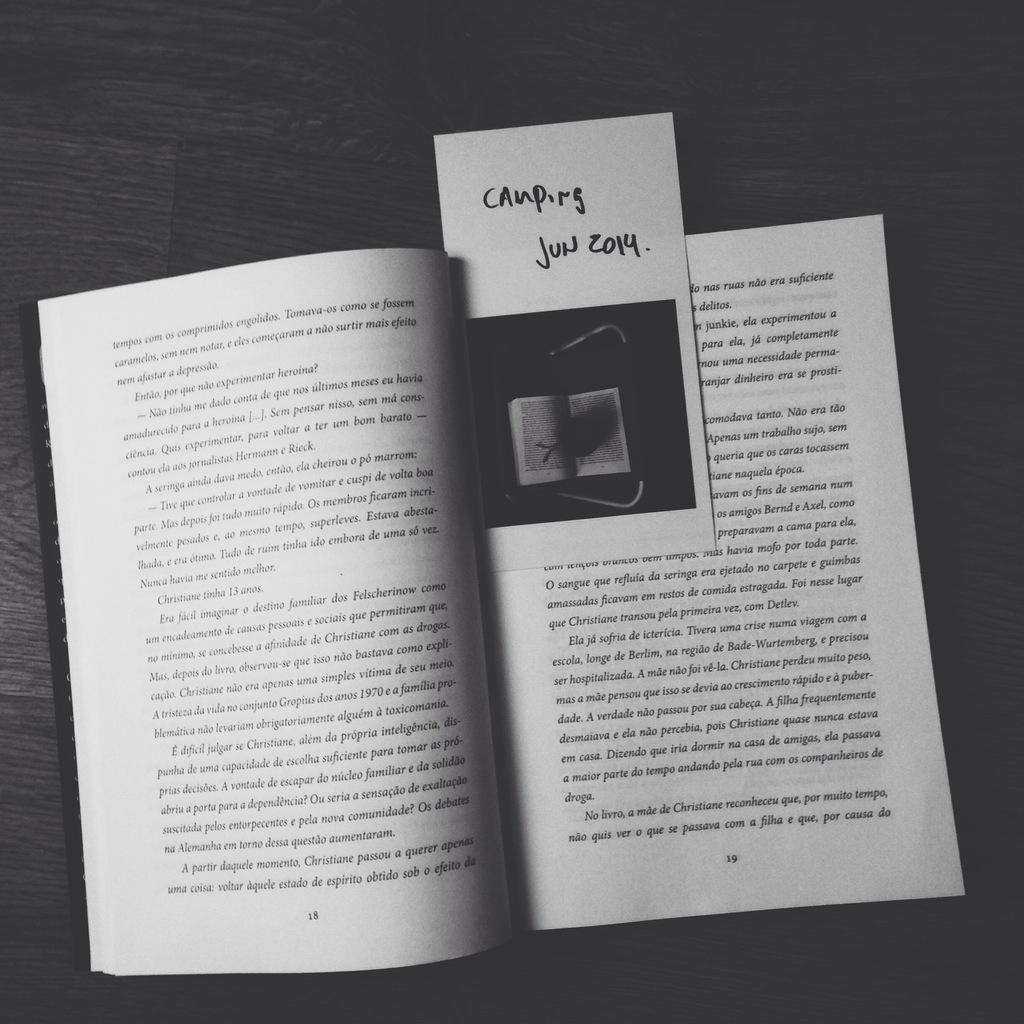<image>
Present a compact description of the photo's key features. A book open to page 18-19 with a book mark in it. 